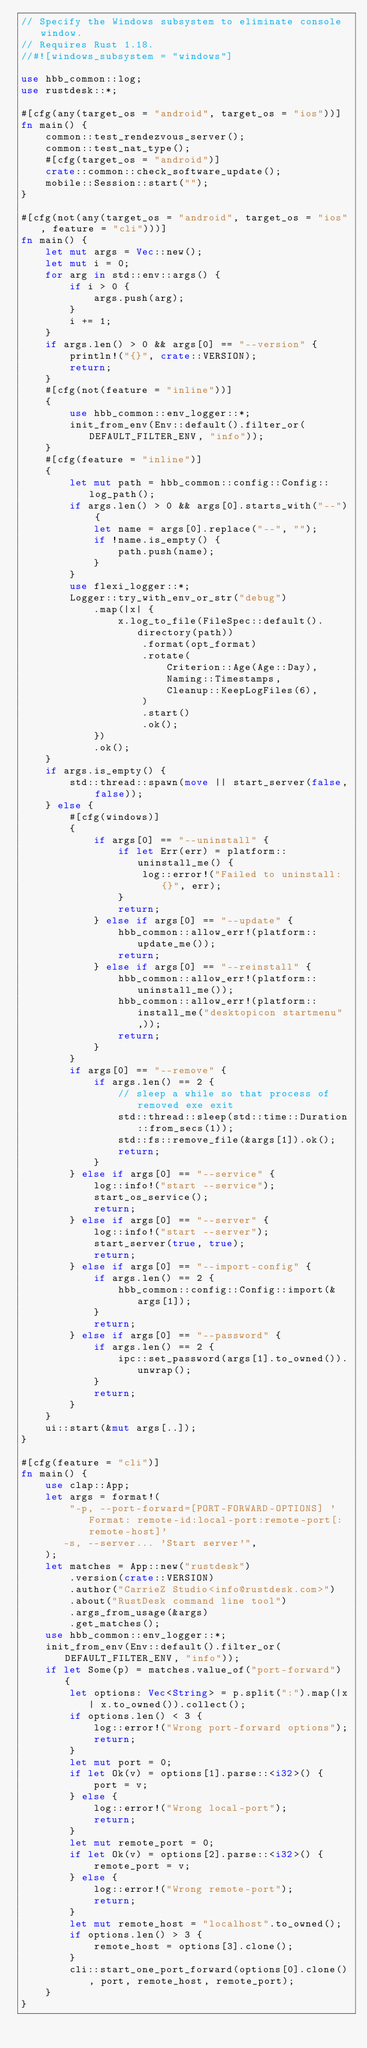<code> <loc_0><loc_0><loc_500><loc_500><_Rust_>// Specify the Windows subsystem to eliminate console window.
// Requires Rust 1.18.
//#![windows_subsystem = "windows"]

use hbb_common::log;
use rustdesk::*;

#[cfg(any(target_os = "android", target_os = "ios"))]
fn main() {
    common::test_rendezvous_server();
    common::test_nat_type();
    #[cfg(target_os = "android")]
    crate::common::check_software_update();
    mobile::Session::start("");
}

#[cfg(not(any(target_os = "android", target_os = "ios", feature = "cli")))]
fn main() {
    let mut args = Vec::new();
    let mut i = 0;
    for arg in std::env::args() {
        if i > 0 {
            args.push(arg);
        }
        i += 1;
    }
    if args.len() > 0 && args[0] == "--version" {
        println!("{}", crate::VERSION);
        return;
    }
    #[cfg(not(feature = "inline"))]
    {
        use hbb_common::env_logger::*;
        init_from_env(Env::default().filter_or(DEFAULT_FILTER_ENV, "info"));
    }
    #[cfg(feature = "inline")]
    {
        let mut path = hbb_common::config::Config::log_path();
        if args.len() > 0 && args[0].starts_with("--") {
            let name = args[0].replace("--", "");
            if !name.is_empty() {
                path.push(name);
            }
        }
        use flexi_logger::*;
        Logger::try_with_env_or_str("debug")
            .map(|x| {
                x.log_to_file(FileSpec::default().directory(path))
                    .format(opt_format)
                    .rotate(
                        Criterion::Age(Age::Day),
                        Naming::Timestamps,
                        Cleanup::KeepLogFiles(6),
                    )
                    .start()
                    .ok();
            })
            .ok();
    }
    if args.is_empty() {
        std::thread::spawn(move || start_server(false, false));
    } else {
        #[cfg(windows)]
        {
            if args[0] == "--uninstall" {
                if let Err(err) = platform::uninstall_me() {
                    log::error!("Failed to uninstall: {}", err);
                }
                return;
            } else if args[0] == "--update" {
                hbb_common::allow_err!(platform::update_me());
                return;
            } else if args[0] == "--reinstall" {
                hbb_common::allow_err!(platform::uninstall_me());
                hbb_common::allow_err!(platform::install_me("desktopicon startmenu",));
                return;
            }
        }
        if args[0] == "--remove" {
            if args.len() == 2 {
                // sleep a while so that process of removed exe exit
                std::thread::sleep(std::time::Duration::from_secs(1));
                std::fs::remove_file(&args[1]).ok();
                return;
            }
        } else if args[0] == "--service" {
            log::info!("start --service");
            start_os_service();
            return;
        } else if args[0] == "--server" {
            log::info!("start --server");
            start_server(true, true);
            return;
        } else if args[0] == "--import-config" {
            if args.len() == 2 {
                hbb_common::config::Config::import(&args[1]);
            }
            return;
        } else if args[0] == "--password" {
            if args.len() == 2 {
                ipc::set_password(args[1].to_owned()).unwrap();
            }
            return;
        }
    }
    ui::start(&mut args[..]);
}

#[cfg(feature = "cli")]
fn main() {
    use clap::App;
    let args = format!(
        "-p, --port-forward=[PORT-FORWARD-OPTIONS] 'Format: remote-id:local-port:remote-port[:remote-host]'
       -s, --server... 'Start server'",
    );
    let matches = App::new("rustdesk")
        .version(crate::VERSION)
        .author("CarrieZ Studio<info@rustdesk.com>")
        .about("RustDesk command line tool")
        .args_from_usage(&args)
        .get_matches();
    use hbb_common::env_logger::*;
    init_from_env(Env::default().filter_or(DEFAULT_FILTER_ENV, "info"));
    if let Some(p) = matches.value_of("port-forward") {
        let options: Vec<String> = p.split(":").map(|x| x.to_owned()).collect();
        if options.len() < 3 {
            log::error!("Wrong port-forward options");
            return;
        }
        let mut port = 0;
        if let Ok(v) = options[1].parse::<i32>() {
            port = v;
        } else {
            log::error!("Wrong local-port");
            return;
        }
        let mut remote_port = 0;
        if let Ok(v) = options[2].parse::<i32>() {
            remote_port = v;
        } else {
            log::error!("Wrong remote-port");
            return;
        }
        let mut remote_host = "localhost".to_owned();
        if options.len() > 3 {
            remote_host = options[3].clone();
        }
        cli::start_one_port_forward(options[0].clone(), port, remote_host, remote_port);
    }
}
</code> 